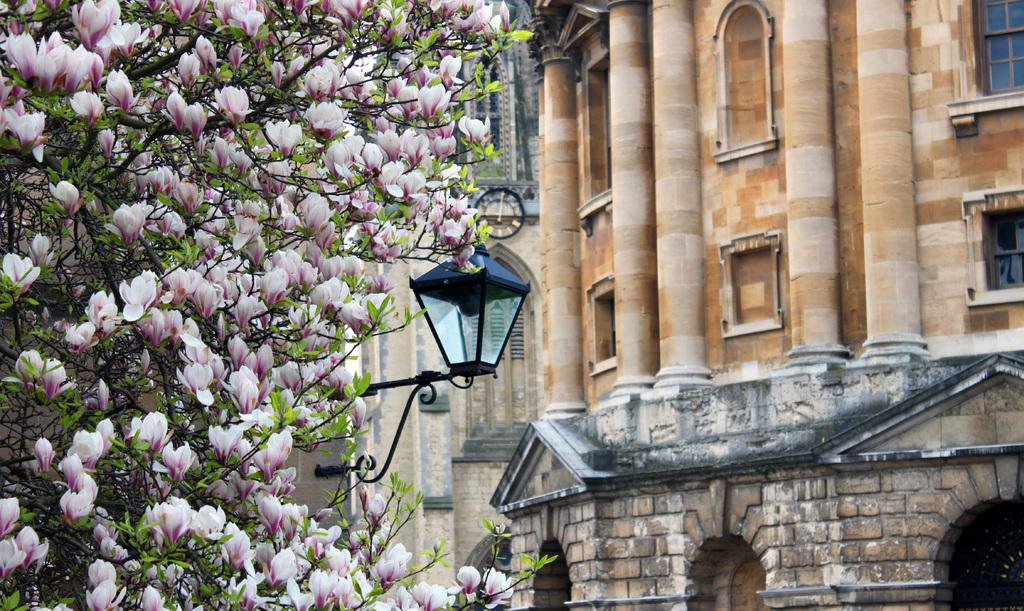What type of vegetation can be seen on a tree in the image? There are flowers on a tree in the image. What object is located in the foreground area of the image? There is a lamp in the foreground area of the image. What type of structures can be seen in the background of the image? There are buildings in the background of the image. What type of rice is being cooked in the pot in the image? There is no pot or rice present in the image; it features flowers on a tree, a lamp in the foreground, and buildings in the background. What type of town is depicted in the image? The image does not depict a town; it shows flowers on a tree, a lamp, and buildings in the background. 